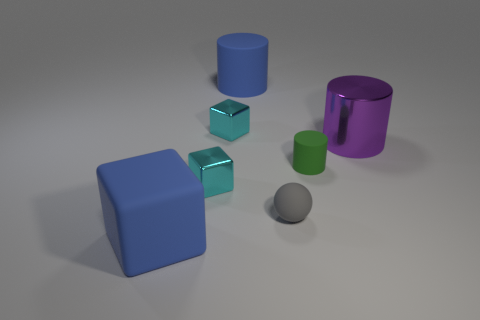Subtract 1 blocks. How many blocks are left? 2 Add 1 big gray blocks. How many objects exist? 8 Add 3 green matte cylinders. How many green matte cylinders are left? 4 Add 5 cyan blocks. How many cyan blocks exist? 7 Subtract 0 red balls. How many objects are left? 7 Subtract all balls. How many objects are left? 6 Subtract all purple cylinders. Subtract all big rubber objects. How many objects are left? 4 